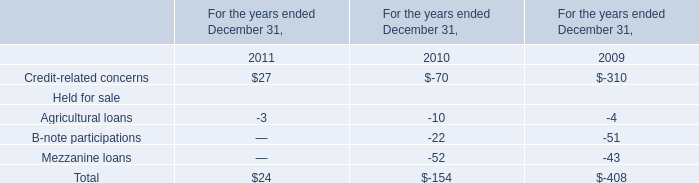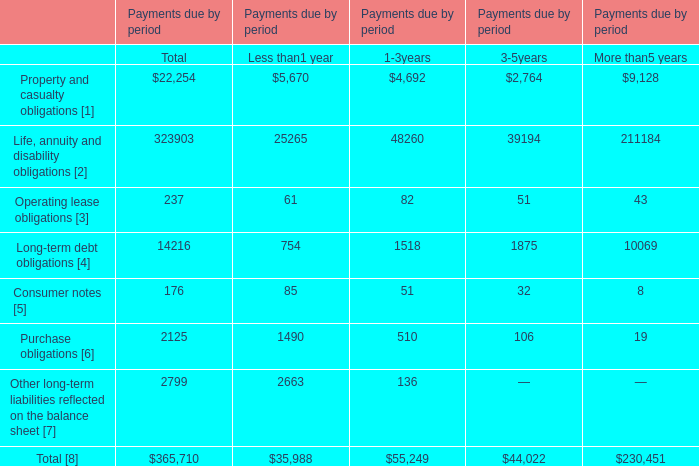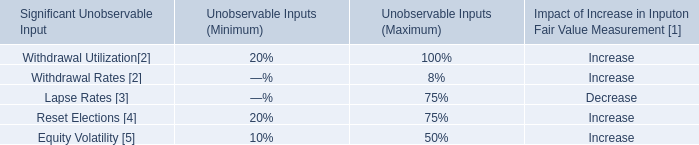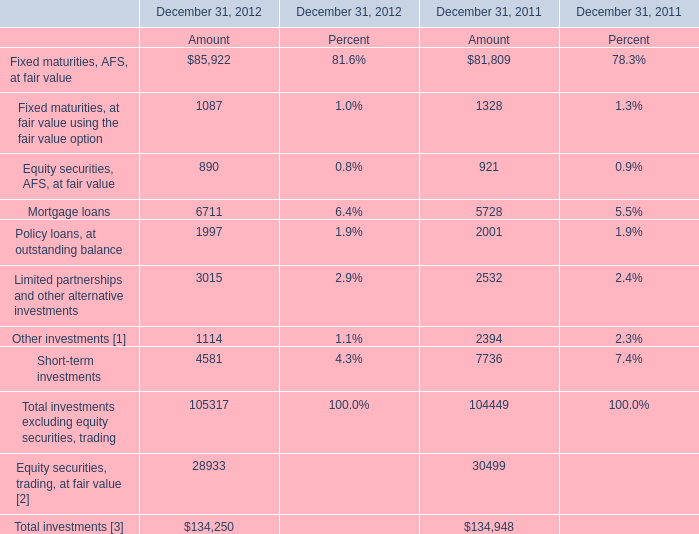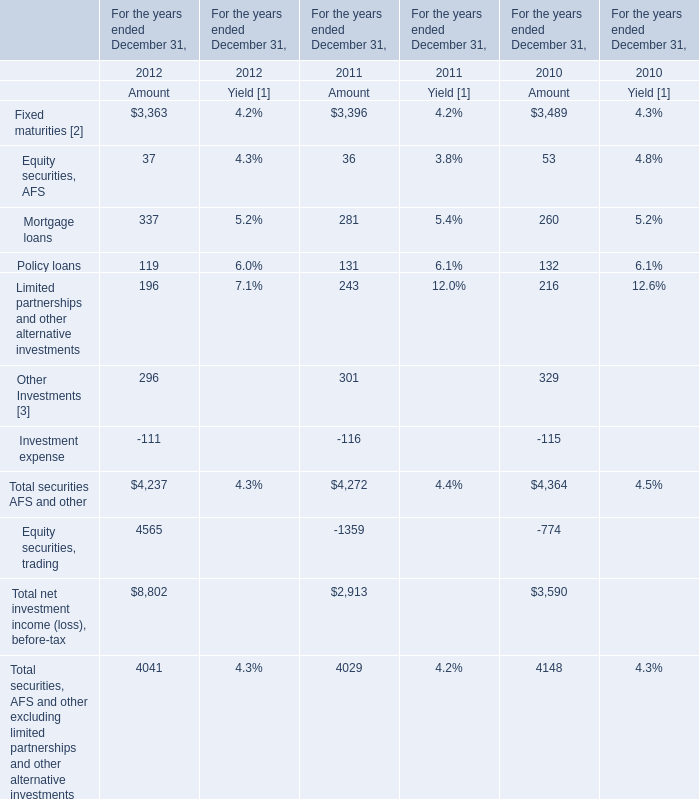What's the sum of all Total securities AFS and other that are positive in 2012? 
Computations: (((((3363 + 37) + 337) + 119) + 196) + 296)
Answer: 4348.0. 